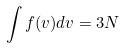Convert formula to latex. <formula><loc_0><loc_0><loc_500><loc_500>\int f ( v ) d v = 3 N</formula> 